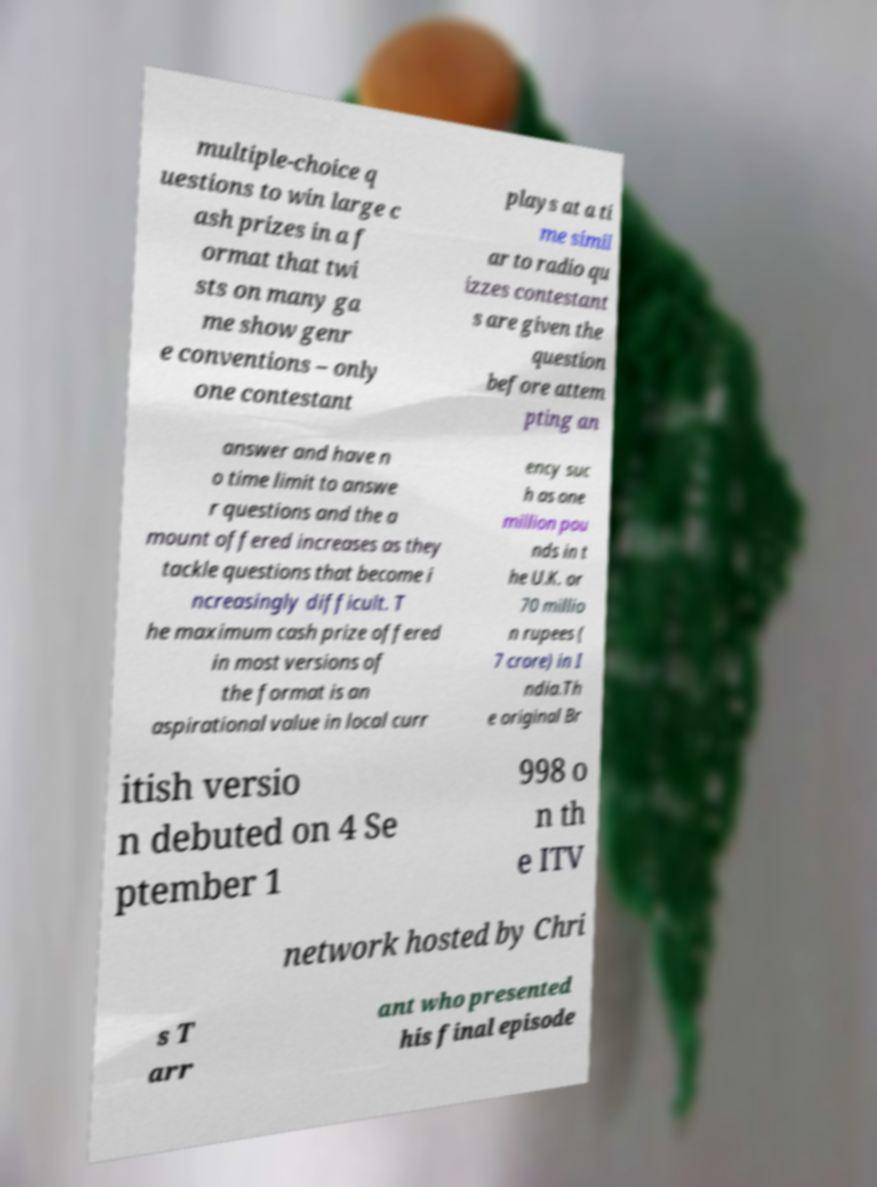There's text embedded in this image that I need extracted. Can you transcribe it verbatim? multiple-choice q uestions to win large c ash prizes in a f ormat that twi sts on many ga me show genr e conventions – only one contestant plays at a ti me simil ar to radio qu izzes contestant s are given the question before attem pting an answer and have n o time limit to answe r questions and the a mount offered increases as they tackle questions that become i ncreasingly difficult. T he maximum cash prize offered in most versions of the format is an aspirational value in local curr ency suc h as one million pou nds in t he U.K. or 70 millio n rupees ( 7 crore) in I ndia.Th e original Br itish versio n debuted on 4 Se ptember 1 998 o n th e ITV network hosted by Chri s T arr ant who presented his final episode 